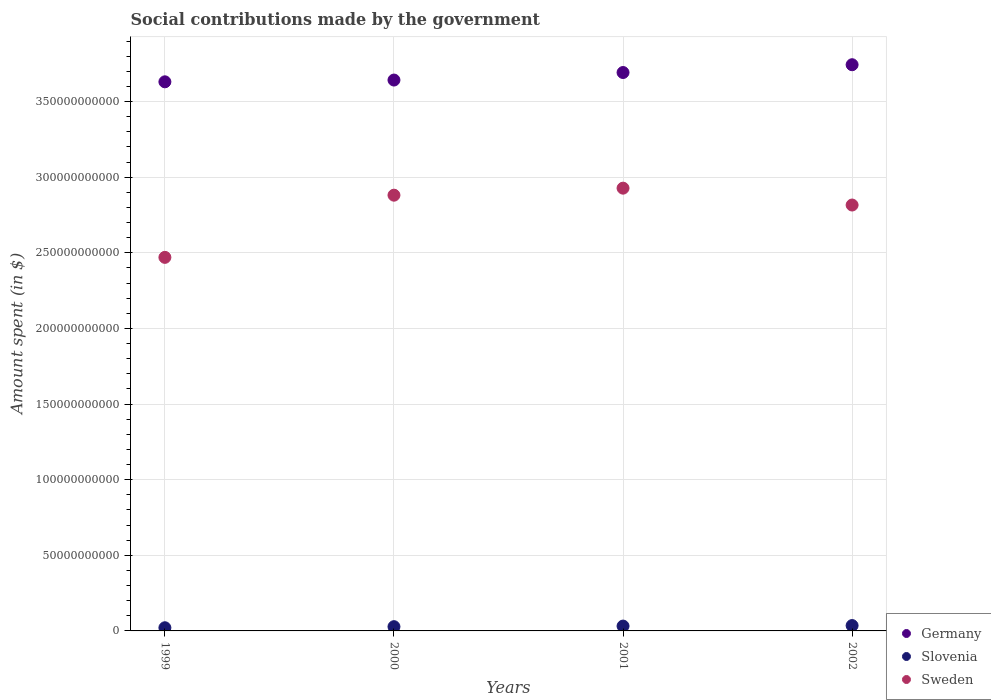How many different coloured dotlines are there?
Offer a terse response. 3. What is the amount spent on social contributions in Slovenia in 2002?
Your response must be concise. 3.54e+09. Across all years, what is the maximum amount spent on social contributions in Slovenia?
Give a very brief answer. 3.54e+09. Across all years, what is the minimum amount spent on social contributions in Germany?
Your answer should be compact. 3.63e+11. What is the total amount spent on social contributions in Slovenia in the graph?
Ensure brevity in your answer.  1.16e+1. What is the difference between the amount spent on social contributions in Slovenia in 2001 and that in 2002?
Your answer should be compact. -3.45e+08. What is the difference between the amount spent on social contributions in Slovenia in 1999 and the amount spent on social contributions in Germany in 2000?
Make the answer very short. -3.62e+11. What is the average amount spent on social contributions in Sweden per year?
Make the answer very short. 2.77e+11. In the year 2001, what is the difference between the amount spent on social contributions in Sweden and amount spent on social contributions in Germany?
Provide a short and direct response. -7.65e+1. What is the ratio of the amount spent on social contributions in Slovenia in 2000 to that in 2001?
Your answer should be compact. 0.88. What is the difference between the highest and the second highest amount spent on social contributions in Slovenia?
Your answer should be compact. 3.45e+08. What is the difference between the highest and the lowest amount spent on social contributions in Slovenia?
Offer a terse response. 1.44e+09. In how many years, is the amount spent on social contributions in Sweden greater than the average amount spent on social contributions in Sweden taken over all years?
Provide a succinct answer. 3. Is the sum of the amount spent on social contributions in Slovenia in 1999 and 2002 greater than the maximum amount spent on social contributions in Sweden across all years?
Give a very brief answer. No. Is it the case that in every year, the sum of the amount spent on social contributions in Sweden and amount spent on social contributions in Slovenia  is greater than the amount spent on social contributions in Germany?
Your response must be concise. No. How many dotlines are there?
Offer a terse response. 3. How many years are there in the graph?
Your response must be concise. 4. What is the difference between two consecutive major ticks on the Y-axis?
Make the answer very short. 5.00e+1. Are the values on the major ticks of Y-axis written in scientific E-notation?
Your response must be concise. No. Where does the legend appear in the graph?
Give a very brief answer. Bottom right. How are the legend labels stacked?
Your response must be concise. Vertical. What is the title of the graph?
Keep it short and to the point. Social contributions made by the government. Does "Albania" appear as one of the legend labels in the graph?
Offer a terse response. No. What is the label or title of the X-axis?
Provide a short and direct response. Years. What is the label or title of the Y-axis?
Your answer should be compact. Amount spent (in $). What is the Amount spent (in $) in Germany in 1999?
Offer a very short reply. 3.63e+11. What is the Amount spent (in $) in Slovenia in 1999?
Ensure brevity in your answer.  2.10e+09. What is the Amount spent (in $) in Sweden in 1999?
Provide a short and direct response. 2.47e+11. What is the Amount spent (in $) in Germany in 2000?
Your answer should be very brief. 3.64e+11. What is the Amount spent (in $) of Slovenia in 2000?
Your answer should be very brief. 2.81e+09. What is the Amount spent (in $) of Sweden in 2000?
Make the answer very short. 2.88e+11. What is the Amount spent (in $) of Germany in 2001?
Ensure brevity in your answer.  3.69e+11. What is the Amount spent (in $) in Slovenia in 2001?
Ensure brevity in your answer.  3.19e+09. What is the Amount spent (in $) in Sweden in 2001?
Ensure brevity in your answer.  2.93e+11. What is the Amount spent (in $) of Germany in 2002?
Provide a short and direct response. 3.74e+11. What is the Amount spent (in $) in Slovenia in 2002?
Your answer should be very brief. 3.54e+09. What is the Amount spent (in $) of Sweden in 2002?
Provide a short and direct response. 2.82e+11. Across all years, what is the maximum Amount spent (in $) in Germany?
Make the answer very short. 3.74e+11. Across all years, what is the maximum Amount spent (in $) of Slovenia?
Your response must be concise. 3.54e+09. Across all years, what is the maximum Amount spent (in $) in Sweden?
Ensure brevity in your answer.  2.93e+11. Across all years, what is the minimum Amount spent (in $) of Germany?
Your response must be concise. 3.63e+11. Across all years, what is the minimum Amount spent (in $) in Slovenia?
Give a very brief answer. 2.10e+09. Across all years, what is the minimum Amount spent (in $) of Sweden?
Offer a terse response. 2.47e+11. What is the total Amount spent (in $) in Germany in the graph?
Your answer should be compact. 1.47e+12. What is the total Amount spent (in $) of Slovenia in the graph?
Keep it short and to the point. 1.16e+1. What is the total Amount spent (in $) in Sweden in the graph?
Offer a very short reply. 1.11e+12. What is the difference between the Amount spent (in $) of Germany in 1999 and that in 2000?
Ensure brevity in your answer.  -1.17e+09. What is the difference between the Amount spent (in $) in Slovenia in 1999 and that in 2000?
Provide a short and direct response. -7.12e+08. What is the difference between the Amount spent (in $) in Sweden in 1999 and that in 2000?
Keep it short and to the point. -4.11e+1. What is the difference between the Amount spent (in $) of Germany in 1999 and that in 2001?
Keep it short and to the point. -6.15e+09. What is the difference between the Amount spent (in $) of Slovenia in 1999 and that in 2001?
Offer a terse response. -1.10e+09. What is the difference between the Amount spent (in $) in Sweden in 1999 and that in 2001?
Ensure brevity in your answer.  -4.58e+1. What is the difference between the Amount spent (in $) of Germany in 1999 and that in 2002?
Your answer should be very brief. -1.13e+1. What is the difference between the Amount spent (in $) in Slovenia in 1999 and that in 2002?
Make the answer very short. -1.44e+09. What is the difference between the Amount spent (in $) of Sweden in 1999 and that in 2002?
Make the answer very short. -3.46e+1. What is the difference between the Amount spent (in $) in Germany in 2000 and that in 2001?
Offer a terse response. -4.98e+09. What is the difference between the Amount spent (in $) of Slovenia in 2000 and that in 2001?
Offer a very short reply. -3.85e+08. What is the difference between the Amount spent (in $) in Sweden in 2000 and that in 2001?
Keep it short and to the point. -4.64e+09. What is the difference between the Amount spent (in $) of Germany in 2000 and that in 2002?
Ensure brevity in your answer.  -1.01e+1. What is the difference between the Amount spent (in $) in Slovenia in 2000 and that in 2002?
Offer a very short reply. -7.30e+08. What is the difference between the Amount spent (in $) of Sweden in 2000 and that in 2002?
Your answer should be compact. 6.51e+09. What is the difference between the Amount spent (in $) in Germany in 2001 and that in 2002?
Keep it short and to the point. -5.15e+09. What is the difference between the Amount spent (in $) in Slovenia in 2001 and that in 2002?
Keep it short and to the point. -3.45e+08. What is the difference between the Amount spent (in $) of Sweden in 2001 and that in 2002?
Your response must be concise. 1.12e+1. What is the difference between the Amount spent (in $) in Germany in 1999 and the Amount spent (in $) in Slovenia in 2000?
Give a very brief answer. 3.60e+11. What is the difference between the Amount spent (in $) of Germany in 1999 and the Amount spent (in $) of Sweden in 2000?
Keep it short and to the point. 7.49e+1. What is the difference between the Amount spent (in $) of Slovenia in 1999 and the Amount spent (in $) of Sweden in 2000?
Your answer should be very brief. -2.86e+11. What is the difference between the Amount spent (in $) in Germany in 1999 and the Amount spent (in $) in Slovenia in 2001?
Make the answer very short. 3.60e+11. What is the difference between the Amount spent (in $) of Germany in 1999 and the Amount spent (in $) of Sweden in 2001?
Your response must be concise. 7.03e+1. What is the difference between the Amount spent (in $) in Slovenia in 1999 and the Amount spent (in $) in Sweden in 2001?
Your answer should be compact. -2.91e+11. What is the difference between the Amount spent (in $) in Germany in 1999 and the Amount spent (in $) in Slovenia in 2002?
Your response must be concise. 3.59e+11. What is the difference between the Amount spent (in $) of Germany in 1999 and the Amount spent (in $) of Sweden in 2002?
Your answer should be very brief. 8.15e+1. What is the difference between the Amount spent (in $) in Slovenia in 1999 and the Amount spent (in $) in Sweden in 2002?
Provide a short and direct response. -2.79e+11. What is the difference between the Amount spent (in $) in Germany in 2000 and the Amount spent (in $) in Slovenia in 2001?
Offer a terse response. 3.61e+11. What is the difference between the Amount spent (in $) in Germany in 2000 and the Amount spent (in $) in Sweden in 2001?
Provide a short and direct response. 7.15e+1. What is the difference between the Amount spent (in $) in Slovenia in 2000 and the Amount spent (in $) in Sweden in 2001?
Your response must be concise. -2.90e+11. What is the difference between the Amount spent (in $) in Germany in 2000 and the Amount spent (in $) in Slovenia in 2002?
Offer a terse response. 3.61e+11. What is the difference between the Amount spent (in $) in Germany in 2000 and the Amount spent (in $) in Sweden in 2002?
Offer a very short reply. 8.26e+1. What is the difference between the Amount spent (in $) in Slovenia in 2000 and the Amount spent (in $) in Sweden in 2002?
Give a very brief answer. -2.79e+11. What is the difference between the Amount spent (in $) of Germany in 2001 and the Amount spent (in $) of Slovenia in 2002?
Provide a succinct answer. 3.66e+11. What is the difference between the Amount spent (in $) of Germany in 2001 and the Amount spent (in $) of Sweden in 2002?
Keep it short and to the point. 8.76e+1. What is the difference between the Amount spent (in $) in Slovenia in 2001 and the Amount spent (in $) in Sweden in 2002?
Your answer should be compact. -2.78e+11. What is the average Amount spent (in $) of Germany per year?
Keep it short and to the point. 3.68e+11. What is the average Amount spent (in $) of Slovenia per year?
Offer a terse response. 2.91e+09. What is the average Amount spent (in $) of Sweden per year?
Offer a terse response. 2.77e+11. In the year 1999, what is the difference between the Amount spent (in $) in Germany and Amount spent (in $) in Slovenia?
Ensure brevity in your answer.  3.61e+11. In the year 1999, what is the difference between the Amount spent (in $) of Germany and Amount spent (in $) of Sweden?
Provide a succinct answer. 1.16e+11. In the year 1999, what is the difference between the Amount spent (in $) in Slovenia and Amount spent (in $) in Sweden?
Your answer should be compact. -2.45e+11. In the year 2000, what is the difference between the Amount spent (in $) in Germany and Amount spent (in $) in Slovenia?
Offer a very short reply. 3.61e+11. In the year 2000, what is the difference between the Amount spent (in $) in Germany and Amount spent (in $) in Sweden?
Your answer should be very brief. 7.61e+1. In the year 2000, what is the difference between the Amount spent (in $) of Slovenia and Amount spent (in $) of Sweden?
Give a very brief answer. -2.85e+11. In the year 2001, what is the difference between the Amount spent (in $) in Germany and Amount spent (in $) in Slovenia?
Offer a very short reply. 3.66e+11. In the year 2001, what is the difference between the Amount spent (in $) of Germany and Amount spent (in $) of Sweden?
Ensure brevity in your answer.  7.65e+1. In the year 2001, what is the difference between the Amount spent (in $) of Slovenia and Amount spent (in $) of Sweden?
Give a very brief answer. -2.90e+11. In the year 2002, what is the difference between the Amount spent (in $) of Germany and Amount spent (in $) of Slovenia?
Your answer should be very brief. 3.71e+11. In the year 2002, what is the difference between the Amount spent (in $) of Germany and Amount spent (in $) of Sweden?
Provide a succinct answer. 9.28e+1. In the year 2002, what is the difference between the Amount spent (in $) of Slovenia and Amount spent (in $) of Sweden?
Provide a succinct answer. -2.78e+11. What is the ratio of the Amount spent (in $) of Germany in 1999 to that in 2000?
Provide a succinct answer. 1. What is the ratio of the Amount spent (in $) of Slovenia in 1999 to that in 2000?
Keep it short and to the point. 0.75. What is the ratio of the Amount spent (in $) of Sweden in 1999 to that in 2000?
Offer a very short reply. 0.86. What is the ratio of the Amount spent (in $) of Germany in 1999 to that in 2001?
Give a very brief answer. 0.98. What is the ratio of the Amount spent (in $) of Slovenia in 1999 to that in 2001?
Your answer should be very brief. 0.66. What is the ratio of the Amount spent (in $) of Sweden in 1999 to that in 2001?
Ensure brevity in your answer.  0.84. What is the ratio of the Amount spent (in $) in Germany in 1999 to that in 2002?
Give a very brief answer. 0.97. What is the ratio of the Amount spent (in $) of Slovenia in 1999 to that in 2002?
Your response must be concise. 0.59. What is the ratio of the Amount spent (in $) in Sweden in 1999 to that in 2002?
Provide a short and direct response. 0.88. What is the ratio of the Amount spent (in $) of Germany in 2000 to that in 2001?
Keep it short and to the point. 0.99. What is the ratio of the Amount spent (in $) of Slovenia in 2000 to that in 2001?
Make the answer very short. 0.88. What is the ratio of the Amount spent (in $) in Sweden in 2000 to that in 2001?
Offer a very short reply. 0.98. What is the ratio of the Amount spent (in $) in Germany in 2000 to that in 2002?
Offer a very short reply. 0.97. What is the ratio of the Amount spent (in $) in Slovenia in 2000 to that in 2002?
Your answer should be compact. 0.79. What is the ratio of the Amount spent (in $) in Sweden in 2000 to that in 2002?
Make the answer very short. 1.02. What is the ratio of the Amount spent (in $) in Germany in 2001 to that in 2002?
Offer a very short reply. 0.99. What is the ratio of the Amount spent (in $) in Slovenia in 2001 to that in 2002?
Ensure brevity in your answer.  0.9. What is the ratio of the Amount spent (in $) in Sweden in 2001 to that in 2002?
Offer a very short reply. 1.04. What is the difference between the highest and the second highest Amount spent (in $) of Germany?
Your answer should be very brief. 5.15e+09. What is the difference between the highest and the second highest Amount spent (in $) in Slovenia?
Make the answer very short. 3.45e+08. What is the difference between the highest and the second highest Amount spent (in $) of Sweden?
Keep it short and to the point. 4.64e+09. What is the difference between the highest and the lowest Amount spent (in $) in Germany?
Provide a succinct answer. 1.13e+1. What is the difference between the highest and the lowest Amount spent (in $) in Slovenia?
Ensure brevity in your answer.  1.44e+09. What is the difference between the highest and the lowest Amount spent (in $) in Sweden?
Make the answer very short. 4.58e+1. 